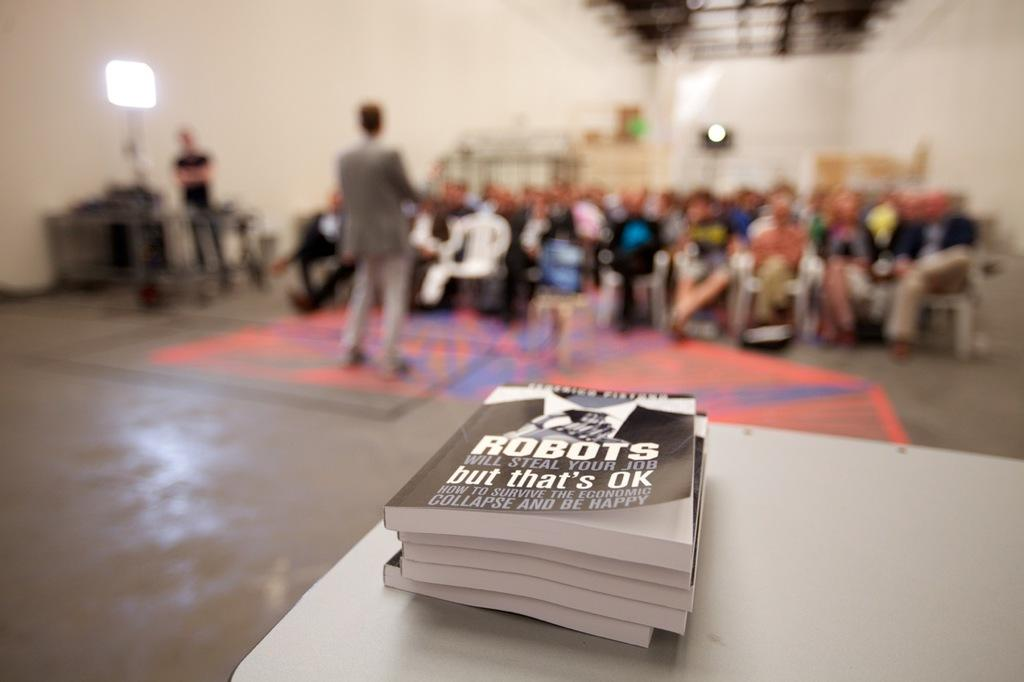<image>
Relay a brief, clear account of the picture shown. people in an auditorium waiting in front of a table with books titled Robots 